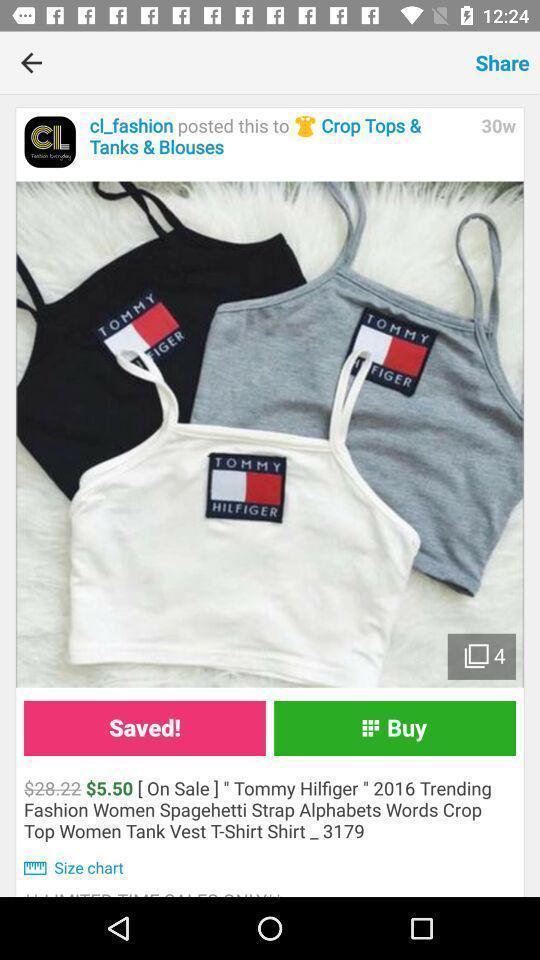Give me a summary of this screen capture. Page showing product details in shopping app. 